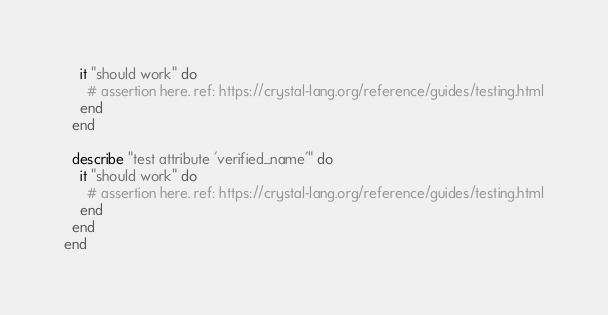<code> <loc_0><loc_0><loc_500><loc_500><_Crystal_>    it "should work" do
      # assertion here. ref: https://crystal-lang.org/reference/guides/testing.html
    end
  end

  describe "test attribute 'verified_name'" do
    it "should work" do
      # assertion here. ref: https://crystal-lang.org/reference/guides/testing.html
    end
  end
end
</code> 